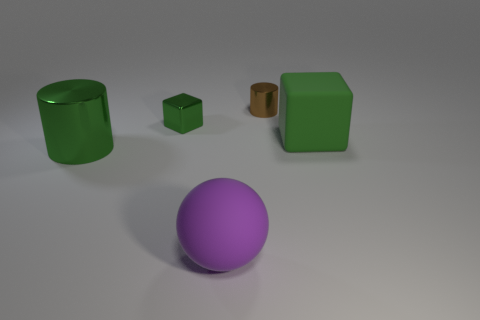What number of large spheres are the same color as the big metal cylinder?
Ensure brevity in your answer.  0. There is a rubber sphere; are there any cylinders behind it?
Give a very brief answer. Yes. Does the small green metallic object have the same shape as the big green object behind the big metal object?
Offer a terse response. Yes. How many things are either matte things that are on the right side of the large purple thing or big cyan shiny spheres?
Ensure brevity in your answer.  1. How many objects are both in front of the small green shiny cube and behind the purple matte object?
Your answer should be very brief. 2. What number of things are green things that are right of the big green metallic cylinder or matte things on the left side of the tiny metal cylinder?
Offer a terse response. 3. What number of other objects are there of the same shape as the large green matte thing?
Offer a terse response. 1. There is a large matte thing that is right of the purple sphere; is its color the same as the big shiny cylinder?
Your answer should be very brief. Yes. What number of other things are there of the same size as the green cylinder?
Ensure brevity in your answer.  2. Do the small green object and the big block have the same material?
Provide a short and direct response. No. 